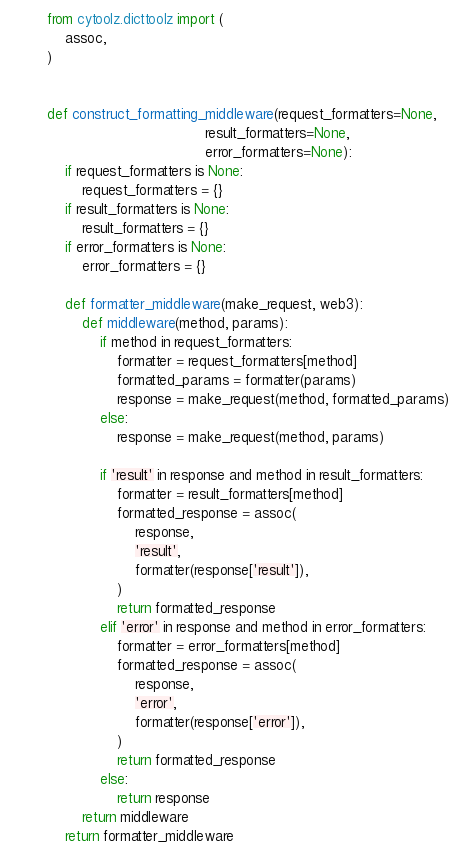Convert code to text. <code><loc_0><loc_0><loc_500><loc_500><_Python_>from cytoolz.dicttoolz import (
    assoc,
)


def construct_formatting_middleware(request_formatters=None,
                                    result_formatters=None,
                                    error_formatters=None):
    if request_formatters is None:
        request_formatters = {}
    if result_formatters is None:
        result_formatters = {}
    if error_formatters is None:
        error_formatters = {}

    def formatter_middleware(make_request, web3):
        def middleware(method, params):
            if method in request_formatters:
                formatter = request_formatters[method]
                formatted_params = formatter(params)
                response = make_request(method, formatted_params)
            else:
                response = make_request(method, params)

            if 'result' in response and method in result_formatters:
                formatter = result_formatters[method]
                formatted_response = assoc(
                    response,
                    'result',
                    formatter(response['result']),
                )
                return formatted_response
            elif 'error' in response and method in error_formatters:
                formatter = error_formatters[method]
                formatted_response = assoc(
                    response,
                    'error',
                    formatter(response['error']),
                )
                return formatted_response
            else:
                return response
        return middleware
    return formatter_middleware
</code> 